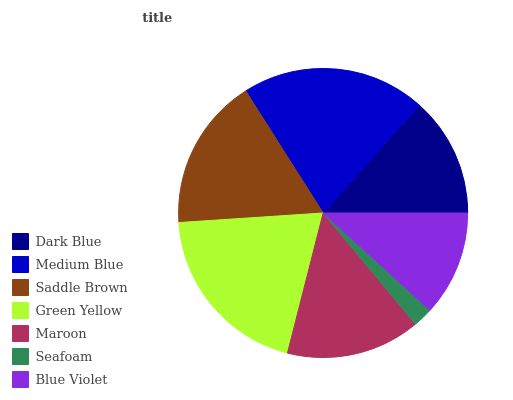Is Seafoam the minimum?
Answer yes or no. Yes. Is Medium Blue the maximum?
Answer yes or no. Yes. Is Saddle Brown the minimum?
Answer yes or no. No. Is Saddle Brown the maximum?
Answer yes or no. No. Is Medium Blue greater than Saddle Brown?
Answer yes or no. Yes. Is Saddle Brown less than Medium Blue?
Answer yes or no. Yes. Is Saddle Brown greater than Medium Blue?
Answer yes or no. No. Is Medium Blue less than Saddle Brown?
Answer yes or no. No. Is Maroon the high median?
Answer yes or no. Yes. Is Maroon the low median?
Answer yes or no. Yes. Is Green Yellow the high median?
Answer yes or no. No. Is Blue Violet the low median?
Answer yes or no. No. 